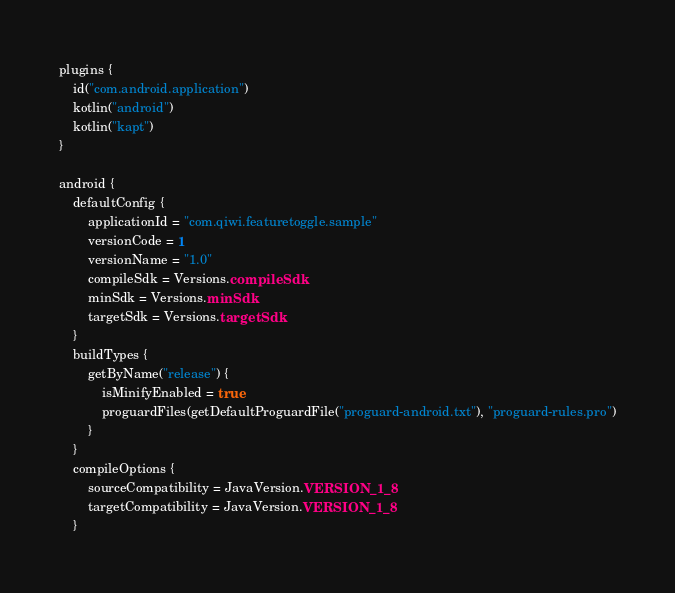<code> <loc_0><loc_0><loc_500><loc_500><_Kotlin_>plugins {
    id("com.android.application")
    kotlin("android")
    kotlin("kapt")
}

android {
    defaultConfig {
        applicationId = "com.qiwi.featuretoggle.sample"
        versionCode = 1
        versionName = "1.0"
        compileSdk = Versions.compileSdk
        minSdk = Versions.minSdk
        targetSdk = Versions.targetSdk
    }
    buildTypes {
        getByName("release") {
            isMinifyEnabled = true
            proguardFiles(getDefaultProguardFile("proguard-android.txt"), "proguard-rules.pro")
        }
    }
    compileOptions {
        sourceCompatibility = JavaVersion.VERSION_1_8
        targetCompatibility = JavaVersion.VERSION_1_8
    }</code> 